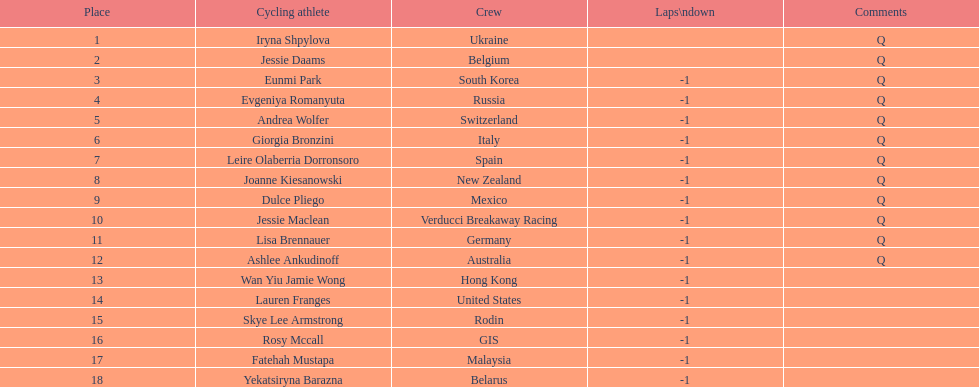What is the number rank of belgium? 2. 